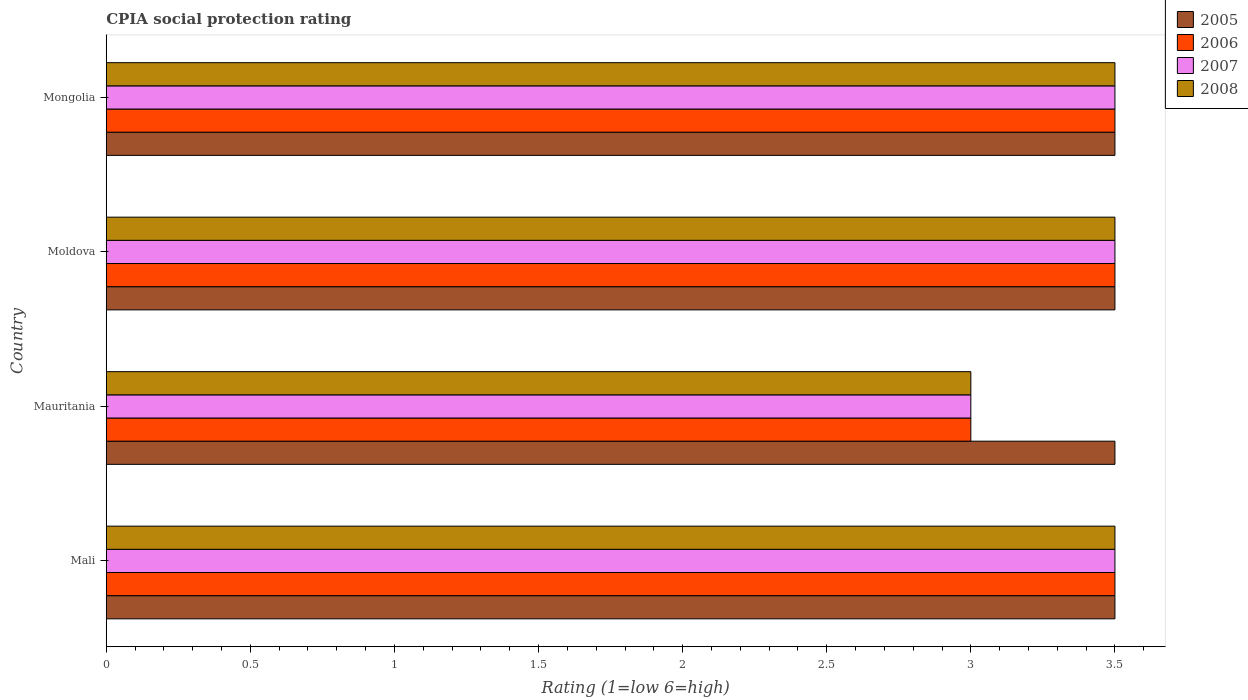How many different coloured bars are there?
Ensure brevity in your answer.  4. How many bars are there on the 2nd tick from the bottom?
Ensure brevity in your answer.  4. What is the label of the 2nd group of bars from the top?
Make the answer very short. Moldova. Across all countries, what is the maximum CPIA rating in 2006?
Your answer should be compact. 3.5. In which country was the CPIA rating in 2005 maximum?
Your answer should be compact. Mali. In which country was the CPIA rating in 2007 minimum?
Make the answer very short. Mauritania. What is the difference between the CPIA rating in 2007 in Moldova and the CPIA rating in 2005 in Mauritania?
Your answer should be very brief. 0. What is the average CPIA rating in 2005 per country?
Your response must be concise. 3.5. What is the ratio of the CPIA rating in 2007 in Mali to that in Moldova?
Offer a very short reply. 1. Is the difference between the CPIA rating in 2008 in Mali and Mauritania greater than the difference between the CPIA rating in 2005 in Mali and Mauritania?
Provide a short and direct response. Yes. What is the difference between the highest and the second highest CPIA rating in 2006?
Provide a succinct answer. 0. In how many countries, is the CPIA rating in 2007 greater than the average CPIA rating in 2007 taken over all countries?
Keep it short and to the point. 3. Is the sum of the CPIA rating in 2005 in Mali and Moldova greater than the maximum CPIA rating in 2006 across all countries?
Provide a succinct answer. Yes. What does the 2nd bar from the bottom in Moldova represents?
Your answer should be very brief. 2006. Are the values on the major ticks of X-axis written in scientific E-notation?
Keep it short and to the point. No. Does the graph contain grids?
Your response must be concise. No. Where does the legend appear in the graph?
Make the answer very short. Top right. How many legend labels are there?
Keep it short and to the point. 4. How are the legend labels stacked?
Your answer should be compact. Vertical. What is the title of the graph?
Provide a short and direct response. CPIA social protection rating. Does "2009" appear as one of the legend labels in the graph?
Your response must be concise. No. What is the label or title of the Y-axis?
Provide a succinct answer. Country. What is the Rating (1=low 6=high) of 2005 in Mali?
Make the answer very short. 3.5. What is the Rating (1=low 6=high) of 2008 in Mali?
Keep it short and to the point. 3.5. What is the Rating (1=low 6=high) in 2008 in Mauritania?
Your response must be concise. 3. What is the Rating (1=low 6=high) in 2007 in Moldova?
Provide a short and direct response. 3.5. What is the Rating (1=low 6=high) of 2005 in Mongolia?
Offer a very short reply. 3.5. What is the Rating (1=low 6=high) in 2007 in Mongolia?
Make the answer very short. 3.5. Across all countries, what is the maximum Rating (1=low 6=high) in 2005?
Offer a very short reply. 3.5. Across all countries, what is the maximum Rating (1=low 6=high) of 2007?
Your response must be concise. 3.5. Across all countries, what is the maximum Rating (1=low 6=high) in 2008?
Your response must be concise. 3.5. Across all countries, what is the minimum Rating (1=low 6=high) in 2008?
Provide a short and direct response. 3. What is the total Rating (1=low 6=high) of 2006 in the graph?
Provide a short and direct response. 13.5. What is the total Rating (1=low 6=high) of 2007 in the graph?
Your answer should be very brief. 13.5. What is the total Rating (1=low 6=high) in 2008 in the graph?
Your answer should be compact. 13.5. What is the difference between the Rating (1=low 6=high) in 2005 in Mali and that in Mauritania?
Offer a terse response. 0. What is the difference between the Rating (1=low 6=high) in 2006 in Mali and that in Mauritania?
Your response must be concise. 0.5. What is the difference between the Rating (1=low 6=high) in 2007 in Mali and that in Mauritania?
Make the answer very short. 0.5. What is the difference between the Rating (1=low 6=high) of 2008 in Mali and that in Mauritania?
Make the answer very short. 0.5. What is the difference between the Rating (1=low 6=high) of 2006 in Mali and that in Mongolia?
Your answer should be compact. 0. What is the difference between the Rating (1=low 6=high) of 2007 in Mali and that in Mongolia?
Make the answer very short. 0. What is the difference between the Rating (1=low 6=high) in 2005 in Mauritania and that in Moldova?
Ensure brevity in your answer.  0. What is the difference between the Rating (1=low 6=high) of 2008 in Mauritania and that in Moldova?
Ensure brevity in your answer.  -0.5. What is the difference between the Rating (1=low 6=high) in 2006 in Mauritania and that in Mongolia?
Make the answer very short. -0.5. What is the difference between the Rating (1=low 6=high) of 2007 in Mauritania and that in Mongolia?
Give a very brief answer. -0.5. What is the difference between the Rating (1=low 6=high) of 2008 in Mauritania and that in Mongolia?
Offer a terse response. -0.5. What is the difference between the Rating (1=low 6=high) in 2006 in Moldova and that in Mongolia?
Your answer should be very brief. 0. What is the difference between the Rating (1=low 6=high) in 2005 in Mali and the Rating (1=low 6=high) in 2006 in Mauritania?
Ensure brevity in your answer.  0.5. What is the difference between the Rating (1=low 6=high) of 2006 in Mali and the Rating (1=low 6=high) of 2007 in Mauritania?
Give a very brief answer. 0.5. What is the difference between the Rating (1=low 6=high) of 2006 in Mali and the Rating (1=low 6=high) of 2008 in Mauritania?
Give a very brief answer. 0.5. What is the difference between the Rating (1=low 6=high) of 2007 in Mali and the Rating (1=low 6=high) of 2008 in Mauritania?
Your answer should be compact. 0.5. What is the difference between the Rating (1=low 6=high) of 2005 in Mali and the Rating (1=low 6=high) of 2006 in Moldova?
Your answer should be very brief. 0. What is the difference between the Rating (1=low 6=high) in 2005 in Mali and the Rating (1=low 6=high) in 2007 in Moldova?
Your answer should be very brief. 0. What is the difference between the Rating (1=low 6=high) in 2005 in Mali and the Rating (1=low 6=high) in 2008 in Moldova?
Offer a very short reply. 0. What is the difference between the Rating (1=low 6=high) of 2007 in Mali and the Rating (1=low 6=high) of 2008 in Moldova?
Make the answer very short. 0. What is the difference between the Rating (1=low 6=high) of 2005 in Mali and the Rating (1=low 6=high) of 2008 in Mongolia?
Your answer should be very brief. 0. What is the difference between the Rating (1=low 6=high) in 2006 in Mali and the Rating (1=low 6=high) in 2008 in Mongolia?
Your answer should be compact. 0. What is the difference between the Rating (1=low 6=high) of 2005 in Mauritania and the Rating (1=low 6=high) of 2007 in Moldova?
Provide a short and direct response. 0. What is the difference between the Rating (1=low 6=high) of 2005 in Mauritania and the Rating (1=low 6=high) of 2008 in Moldova?
Ensure brevity in your answer.  0. What is the difference between the Rating (1=low 6=high) of 2007 in Mauritania and the Rating (1=low 6=high) of 2008 in Moldova?
Keep it short and to the point. -0.5. What is the difference between the Rating (1=low 6=high) in 2005 in Mauritania and the Rating (1=low 6=high) in 2006 in Mongolia?
Keep it short and to the point. 0. What is the difference between the Rating (1=low 6=high) in 2005 in Mauritania and the Rating (1=low 6=high) in 2008 in Mongolia?
Your answer should be very brief. 0. What is the difference between the Rating (1=low 6=high) of 2006 in Mauritania and the Rating (1=low 6=high) of 2007 in Mongolia?
Your answer should be compact. -0.5. What is the difference between the Rating (1=low 6=high) of 2006 in Mauritania and the Rating (1=low 6=high) of 2008 in Mongolia?
Your answer should be compact. -0.5. What is the difference between the Rating (1=low 6=high) of 2007 in Mauritania and the Rating (1=low 6=high) of 2008 in Mongolia?
Offer a very short reply. -0.5. What is the difference between the Rating (1=low 6=high) in 2006 in Moldova and the Rating (1=low 6=high) in 2007 in Mongolia?
Offer a terse response. 0. What is the difference between the Rating (1=low 6=high) in 2006 in Moldova and the Rating (1=low 6=high) in 2008 in Mongolia?
Offer a terse response. 0. What is the difference between the Rating (1=low 6=high) of 2007 in Moldova and the Rating (1=low 6=high) of 2008 in Mongolia?
Provide a short and direct response. 0. What is the average Rating (1=low 6=high) in 2006 per country?
Your answer should be compact. 3.38. What is the average Rating (1=low 6=high) in 2007 per country?
Your answer should be compact. 3.38. What is the average Rating (1=low 6=high) of 2008 per country?
Ensure brevity in your answer.  3.38. What is the difference between the Rating (1=low 6=high) in 2005 and Rating (1=low 6=high) in 2007 in Mali?
Offer a terse response. 0. What is the difference between the Rating (1=low 6=high) in 2006 and Rating (1=low 6=high) in 2007 in Mali?
Provide a short and direct response. 0. What is the difference between the Rating (1=low 6=high) in 2006 and Rating (1=low 6=high) in 2008 in Mali?
Keep it short and to the point. 0. What is the difference between the Rating (1=low 6=high) in 2007 and Rating (1=low 6=high) in 2008 in Mali?
Keep it short and to the point. 0. What is the difference between the Rating (1=low 6=high) in 2005 and Rating (1=low 6=high) in 2006 in Mauritania?
Your answer should be compact. 0.5. What is the difference between the Rating (1=low 6=high) of 2005 and Rating (1=low 6=high) of 2008 in Mauritania?
Keep it short and to the point. 0.5. What is the difference between the Rating (1=low 6=high) of 2006 and Rating (1=low 6=high) of 2007 in Mauritania?
Your answer should be compact. 0. What is the difference between the Rating (1=low 6=high) of 2006 and Rating (1=low 6=high) of 2008 in Mauritania?
Make the answer very short. 0. What is the difference between the Rating (1=low 6=high) of 2007 and Rating (1=low 6=high) of 2008 in Mauritania?
Provide a short and direct response. 0. What is the difference between the Rating (1=low 6=high) in 2005 and Rating (1=low 6=high) in 2008 in Moldova?
Provide a succinct answer. 0. What is the difference between the Rating (1=low 6=high) in 2006 and Rating (1=low 6=high) in 2007 in Moldova?
Your answer should be compact. 0. What is the difference between the Rating (1=low 6=high) in 2007 and Rating (1=low 6=high) in 2008 in Moldova?
Give a very brief answer. 0. What is the difference between the Rating (1=low 6=high) of 2005 and Rating (1=low 6=high) of 2006 in Mongolia?
Provide a succinct answer. 0. What is the difference between the Rating (1=low 6=high) of 2005 and Rating (1=low 6=high) of 2007 in Mongolia?
Ensure brevity in your answer.  0. What is the difference between the Rating (1=low 6=high) in 2006 and Rating (1=low 6=high) in 2008 in Mongolia?
Ensure brevity in your answer.  0. What is the ratio of the Rating (1=low 6=high) in 2005 in Mali to that in Mauritania?
Your answer should be very brief. 1. What is the ratio of the Rating (1=low 6=high) in 2007 in Mali to that in Mauritania?
Make the answer very short. 1.17. What is the ratio of the Rating (1=low 6=high) of 2005 in Mali to that in Moldova?
Offer a very short reply. 1. What is the ratio of the Rating (1=low 6=high) in 2006 in Mali to that in Moldova?
Provide a short and direct response. 1. What is the ratio of the Rating (1=low 6=high) of 2008 in Mali to that in Moldova?
Your answer should be very brief. 1. What is the ratio of the Rating (1=low 6=high) in 2005 in Mali to that in Mongolia?
Your response must be concise. 1. What is the ratio of the Rating (1=low 6=high) in 2006 in Mauritania to that in Moldova?
Offer a very short reply. 0.86. What is the ratio of the Rating (1=low 6=high) in 2007 in Mauritania to that in Moldova?
Offer a terse response. 0.86. What is the ratio of the Rating (1=low 6=high) of 2008 in Mauritania to that in Moldova?
Make the answer very short. 0.86. What is the ratio of the Rating (1=low 6=high) in 2005 in Mauritania to that in Mongolia?
Make the answer very short. 1. What is the ratio of the Rating (1=low 6=high) of 2005 in Moldova to that in Mongolia?
Your answer should be very brief. 1. What is the ratio of the Rating (1=low 6=high) in 2006 in Moldova to that in Mongolia?
Your response must be concise. 1. What is the ratio of the Rating (1=low 6=high) of 2007 in Moldova to that in Mongolia?
Offer a very short reply. 1. What is the ratio of the Rating (1=low 6=high) of 2008 in Moldova to that in Mongolia?
Keep it short and to the point. 1. What is the difference between the highest and the second highest Rating (1=low 6=high) in 2007?
Offer a very short reply. 0. What is the difference between the highest and the lowest Rating (1=low 6=high) of 2005?
Offer a terse response. 0. What is the difference between the highest and the lowest Rating (1=low 6=high) in 2007?
Offer a terse response. 0.5. 